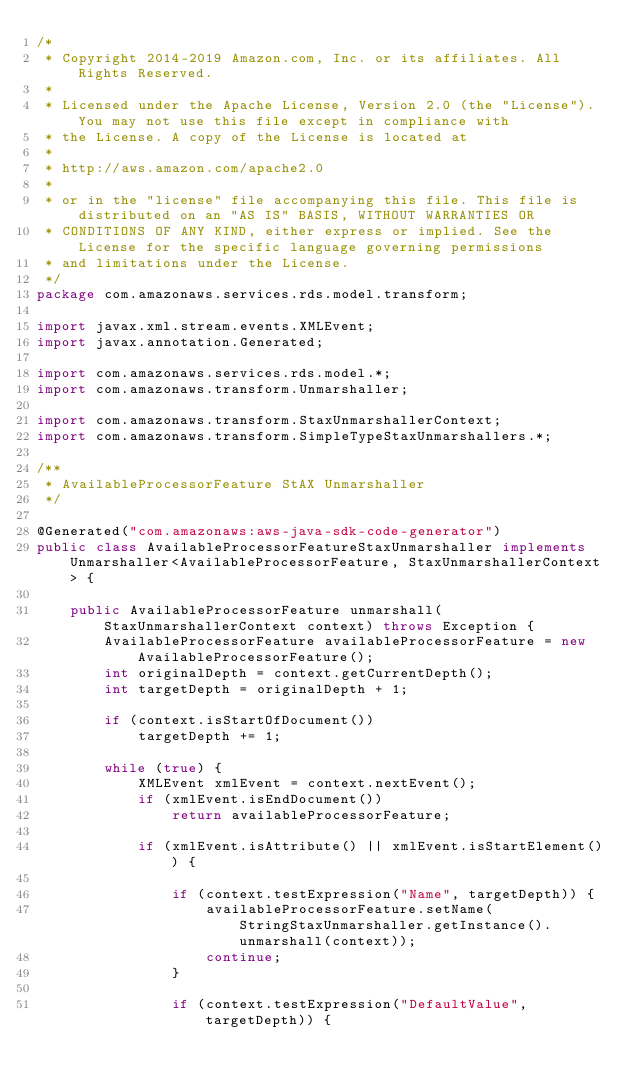Convert code to text. <code><loc_0><loc_0><loc_500><loc_500><_Java_>/*
 * Copyright 2014-2019 Amazon.com, Inc. or its affiliates. All Rights Reserved.
 * 
 * Licensed under the Apache License, Version 2.0 (the "License"). You may not use this file except in compliance with
 * the License. A copy of the License is located at
 * 
 * http://aws.amazon.com/apache2.0
 * 
 * or in the "license" file accompanying this file. This file is distributed on an "AS IS" BASIS, WITHOUT WARRANTIES OR
 * CONDITIONS OF ANY KIND, either express or implied. See the License for the specific language governing permissions
 * and limitations under the License.
 */
package com.amazonaws.services.rds.model.transform;

import javax.xml.stream.events.XMLEvent;
import javax.annotation.Generated;

import com.amazonaws.services.rds.model.*;
import com.amazonaws.transform.Unmarshaller;

import com.amazonaws.transform.StaxUnmarshallerContext;
import com.amazonaws.transform.SimpleTypeStaxUnmarshallers.*;

/**
 * AvailableProcessorFeature StAX Unmarshaller
 */

@Generated("com.amazonaws:aws-java-sdk-code-generator")
public class AvailableProcessorFeatureStaxUnmarshaller implements Unmarshaller<AvailableProcessorFeature, StaxUnmarshallerContext> {

    public AvailableProcessorFeature unmarshall(StaxUnmarshallerContext context) throws Exception {
        AvailableProcessorFeature availableProcessorFeature = new AvailableProcessorFeature();
        int originalDepth = context.getCurrentDepth();
        int targetDepth = originalDepth + 1;

        if (context.isStartOfDocument())
            targetDepth += 1;

        while (true) {
            XMLEvent xmlEvent = context.nextEvent();
            if (xmlEvent.isEndDocument())
                return availableProcessorFeature;

            if (xmlEvent.isAttribute() || xmlEvent.isStartElement()) {

                if (context.testExpression("Name", targetDepth)) {
                    availableProcessorFeature.setName(StringStaxUnmarshaller.getInstance().unmarshall(context));
                    continue;
                }

                if (context.testExpression("DefaultValue", targetDepth)) {</code> 